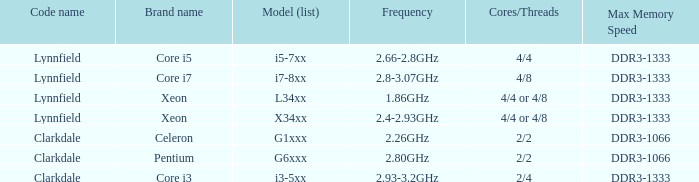Between 2.93 and 3.2 ghz frequencies, what is the top memory speed possible? DDR3-1333. 